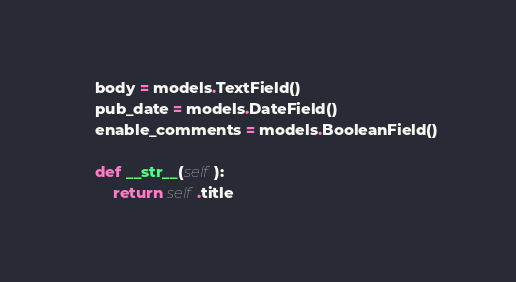Convert code to text. <code><loc_0><loc_0><loc_500><loc_500><_Python_>    body = models.TextField()
    pub_date = models.DateField()
    enable_comments = models.BooleanField()

    def __str__(self):
        return self.title
</code> 